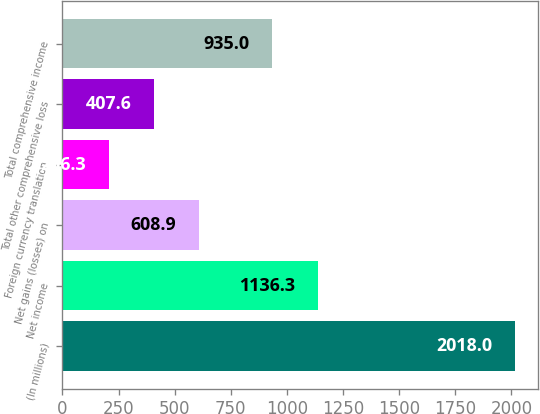<chart> <loc_0><loc_0><loc_500><loc_500><bar_chart><fcel>(In millions)<fcel>Net income<fcel>Net gains (losses) on<fcel>Foreign currency translation<fcel>Total other comprehensive loss<fcel>Total comprehensive income<nl><fcel>2018<fcel>1136.3<fcel>608.9<fcel>206.3<fcel>407.6<fcel>935<nl></chart> 